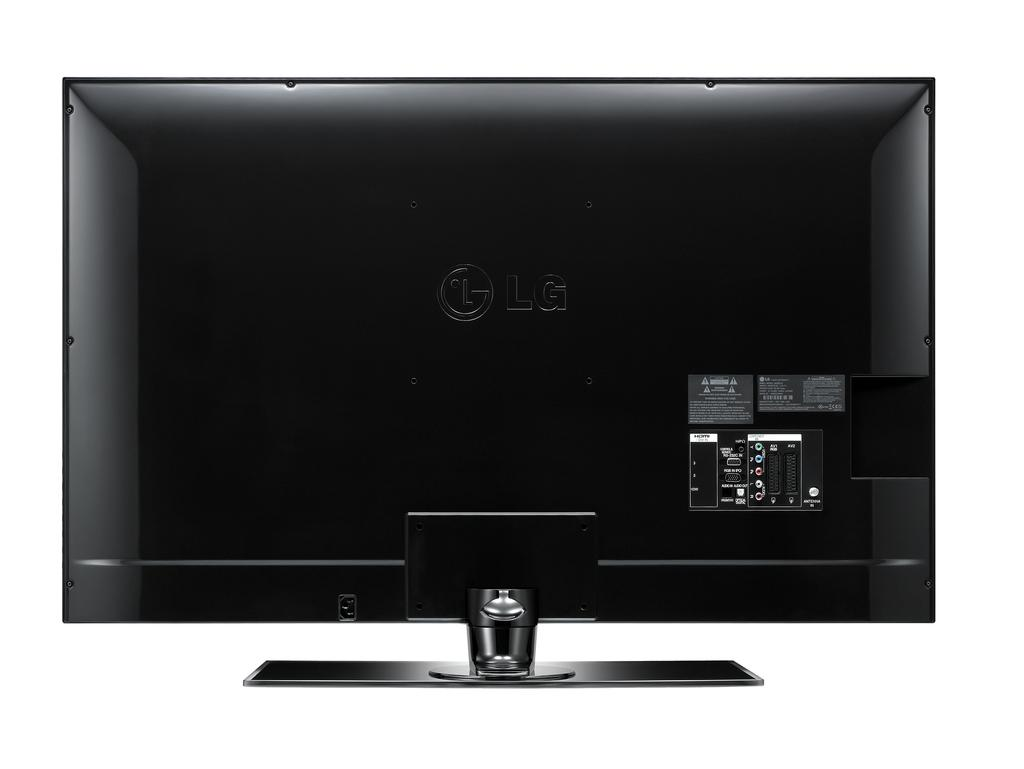<image>
Offer a succinct explanation of the picture presented. An LG television is all black, including the LG logo. 